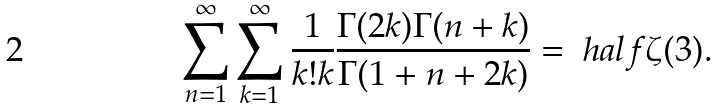Convert formula to latex. <formula><loc_0><loc_0><loc_500><loc_500>\sum _ { n = 1 } ^ { \infty } \sum _ { k = 1 } ^ { \infty } \frac { 1 } { k ! k } \frac { \Gamma ( 2 k ) \Gamma ( n + k ) } { \Gamma ( 1 + n + 2 k ) } = \ h a l f \zeta ( 3 ) .</formula> 